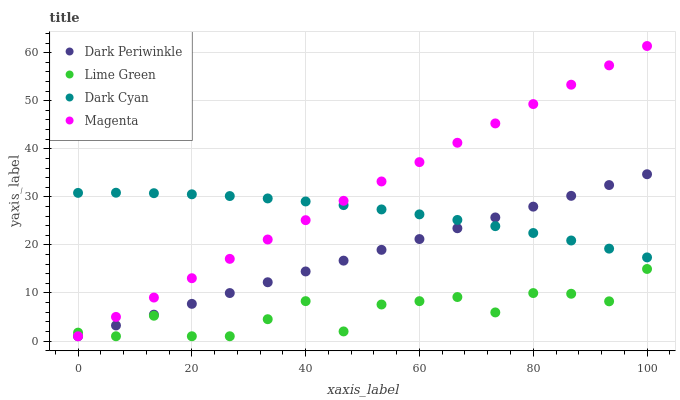Does Lime Green have the minimum area under the curve?
Answer yes or no. Yes. Does Magenta have the maximum area under the curve?
Answer yes or no. Yes. Does Magenta have the minimum area under the curve?
Answer yes or no. No. Does Lime Green have the maximum area under the curve?
Answer yes or no. No. Is Dark Periwinkle the smoothest?
Answer yes or no. Yes. Is Lime Green the roughest?
Answer yes or no. Yes. Is Magenta the smoothest?
Answer yes or no. No. Is Magenta the roughest?
Answer yes or no. No. Does Magenta have the lowest value?
Answer yes or no. Yes. Does Magenta have the highest value?
Answer yes or no. Yes. Does Lime Green have the highest value?
Answer yes or no. No. Is Lime Green less than Dark Cyan?
Answer yes or no. Yes. Is Dark Cyan greater than Lime Green?
Answer yes or no. Yes. Does Dark Cyan intersect Dark Periwinkle?
Answer yes or no. Yes. Is Dark Cyan less than Dark Periwinkle?
Answer yes or no. No. Is Dark Cyan greater than Dark Periwinkle?
Answer yes or no. No. Does Lime Green intersect Dark Cyan?
Answer yes or no. No. 